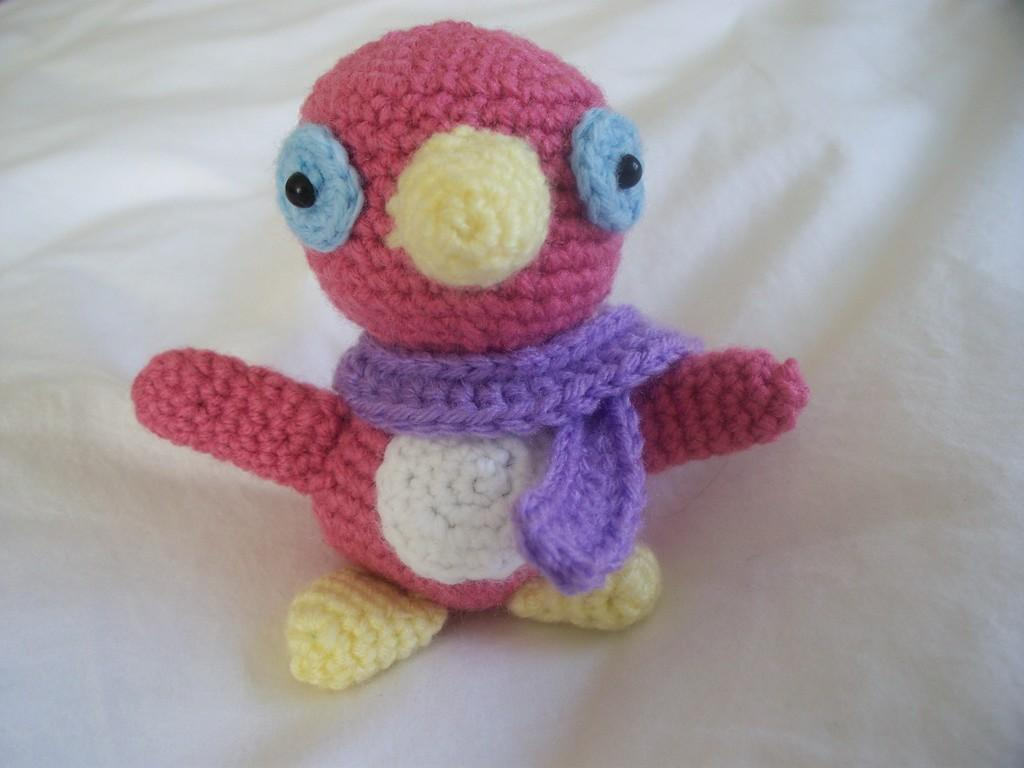What type of object is in the image? There is a knitted soft toy in the image. What shape is the soft toy? The soft toy is in the shape of a bird. What decision does the bird make in the image? There is no indication in the image that the bird is making a decision, as it is a soft toy and not a living creature. 